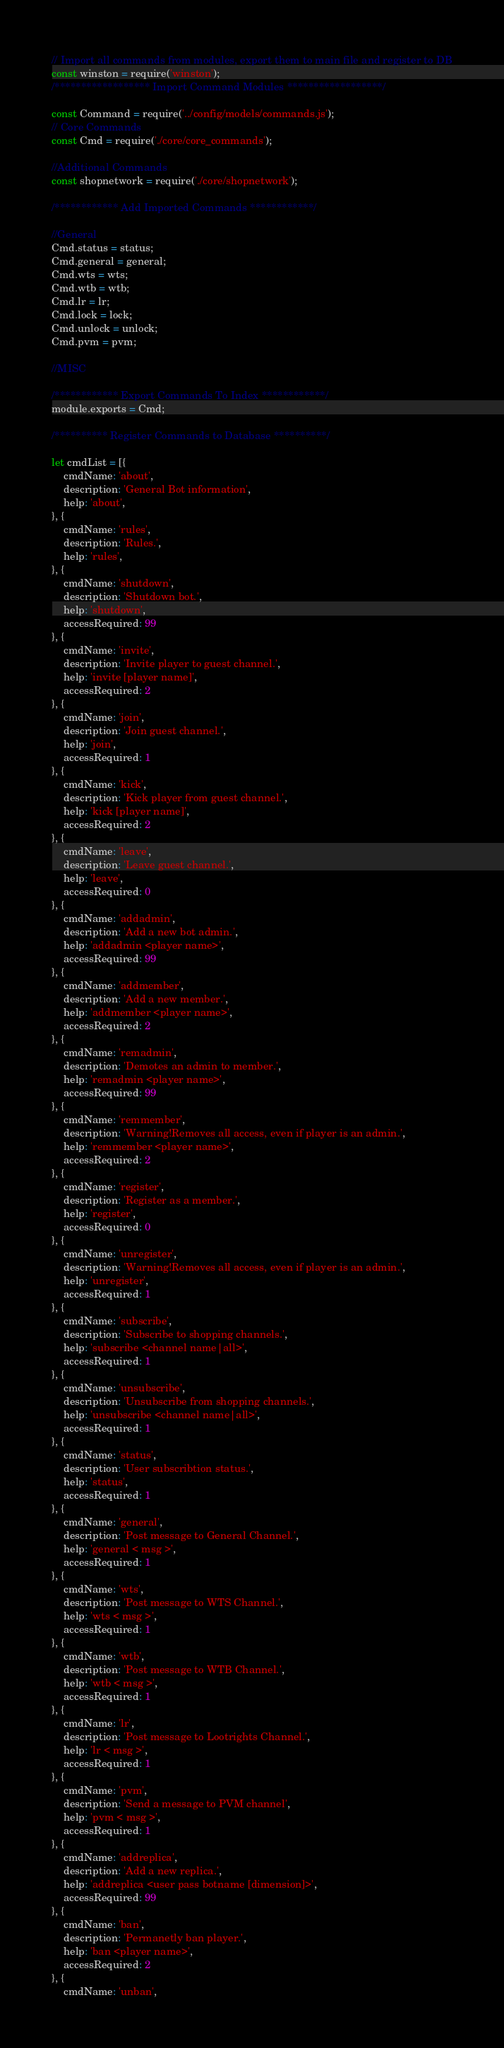Convert code to text. <code><loc_0><loc_0><loc_500><loc_500><_JavaScript_>// Import all commands from modules, export them to main file and register to DB
const winston = require('winston');
/****************** Import Command Modules ******************/

const Command = require('../config/models/commands.js');
// Core Commands
const Cmd = require('./core/core_commands');

//Additional Commands
const shopnetwork = require('./core/shopnetwork');

/************ Add Imported Commands ************/

//General
Cmd.status = status;
Cmd.general = general;
Cmd.wts = wts;
Cmd.wtb = wtb;
Cmd.lr = lr;
Cmd.lock = lock;
Cmd.unlock = unlock;
Cmd.pvm = pvm;

//MISC

/************ Export Commands To Index ************/
module.exports = Cmd;

/********** Register Commands to Database **********/

let cmdList = [{
    cmdName: 'about',
    description: 'General Bot information',
    help: 'about',
}, {
    cmdName: 'rules',
    description: 'Rules.',
    help: 'rules',
}, {
    cmdName: 'shutdown',
    description: 'Shutdown bot.',
    help: 'shutdown',
    accessRequired: 99
}, {
    cmdName: 'invite',
    description: 'Invite player to guest channel.',
    help: 'invite [player name]',
    accessRequired: 2
}, {
    cmdName: 'join',
    description: 'Join guest channel.',
    help: 'join',
    accessRequired: 1
}, {
    cmdName: 'kick',
    description: 'Kick player from guest channel.',
    help: 'kick [player name]',
    accessRequired: 2
}, {
    cmdName: 'leave',
    description: 'Leave guest channel.',
    help: 'leave',
    accessRequired: 0
}, {
    cmdName: 'addadmin',
    description: 'Add a new bot admin.',
    help: 'addadmin <player name>',
    accessRequired: 99
}, {
    cmdName: 'addmember',
    description: 'Add a new member.',
    help: 'addmember <player name>',
    accessRequired: 2
}, {
    cmdName: 'remadmin',
    description: 'Demotes an admin to member.',
    help: 'remadmin <player name>',
    accessRequired: 99
}, {
    cmdName: 'remmember',
    description: 'Warning!Removes all access, even if player is an admin.',
    help: 'remmember <player name>',
    accessRequired: 2
}, {
    cmdName: 'register',
    description: 'Register as a member.',
    help: 'register',
    accessRequired: 0
}, {
    cmdName: 'unregister',
    description: 'Warning!Removes all access, even if player is an admin.',
    help: 'unregister',
    accessRequired: 1
}, {
    cmdName: 'subscribe',
    description: 'Subscribe to shopping channels.',
    help: 'subscribe <channel name|all>',
    accessRequired: 1
}, {
    cmdName: 'unsubscribe',
    description: 'Unsubscribe from shopping channels.',
    help: 'unsubscribe <channel name|all>',
    accessRequired: 1
}, {
    cmdName: 'status',
    description: 'User subscribtion status.',
    help: 'status',
    accessRequired: 1
}, {
    cmdName: 'general',
    description: 'Post message to General Channel.',
    help: 'general < msg >',
    accessRequired: 1
}, {
    cmdName: 'wts',
    description: 'Post message to WTS Channel.',
    help: 'wts < msg >',
    accessRequired: 1
}, {
    cmdName: 'wtb',
    description: 'Post message to WTB Channel.',
    help: 'wtb < msg >',
    accessRequired: 1
}, {
    cmdName: 'lr',
    description: 'Post message to Lootrights Channel.',
    help: 'lr < msg >',
    accessRequired: 1
}, {
    cmdName: 'pvm',
    description: 'Send a message to PVM channel',
    help: 'pvm < msg >',
    accessRequired: 1
}, {
    cmdName: 'addreplica',
    description: 'Add a new replica.',
    help: 'addreplica <user pass botname [dimension]>',
    accessRequired: 99
}, {
    cmdName: 'ban',
    description: 'Permanetly ban player.',
    help: 'ban <player name>',
    accessRequired: 2
}, {
    cmdName: 'unban',</code> 